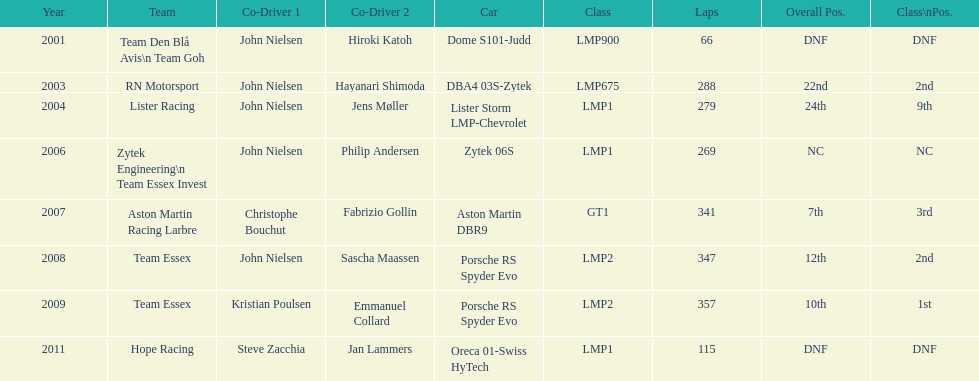Who were the co-drivers for the aston martin dbr9 in 2007? Christophe Bouchut, Fabrizio Gollin. 